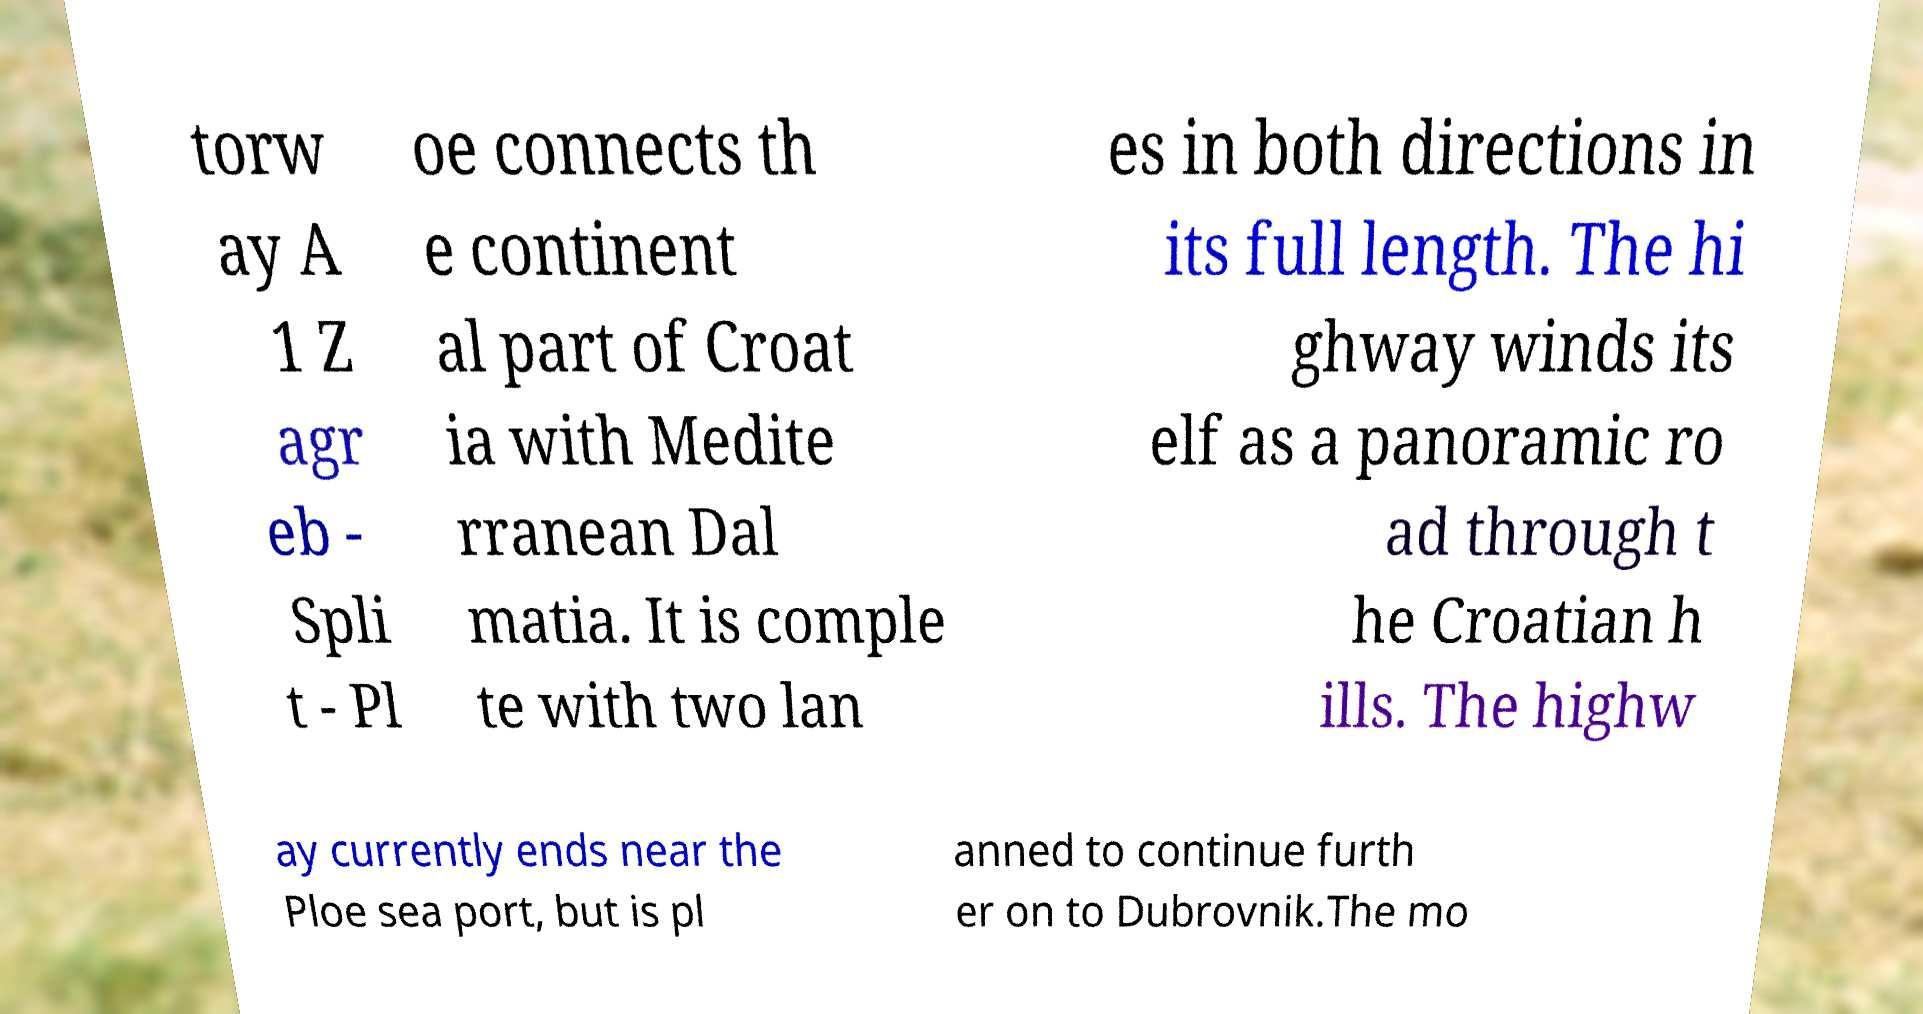Please identify and transcribe the text found in this image. torw ay A 1 Z agr eb - Spli t - Pl oe connects th e continent al part of Croat ia with Medite rranean Dal matia. It is comple te with two lan es in both directions in its full length. The hi ghway winds its elf as a panoramic ro ad through t he Croatian h ills. The highw ay currently ends near the Ploe sea port, but is pl anned to continue furth er on to Dubrovnik.The mo 